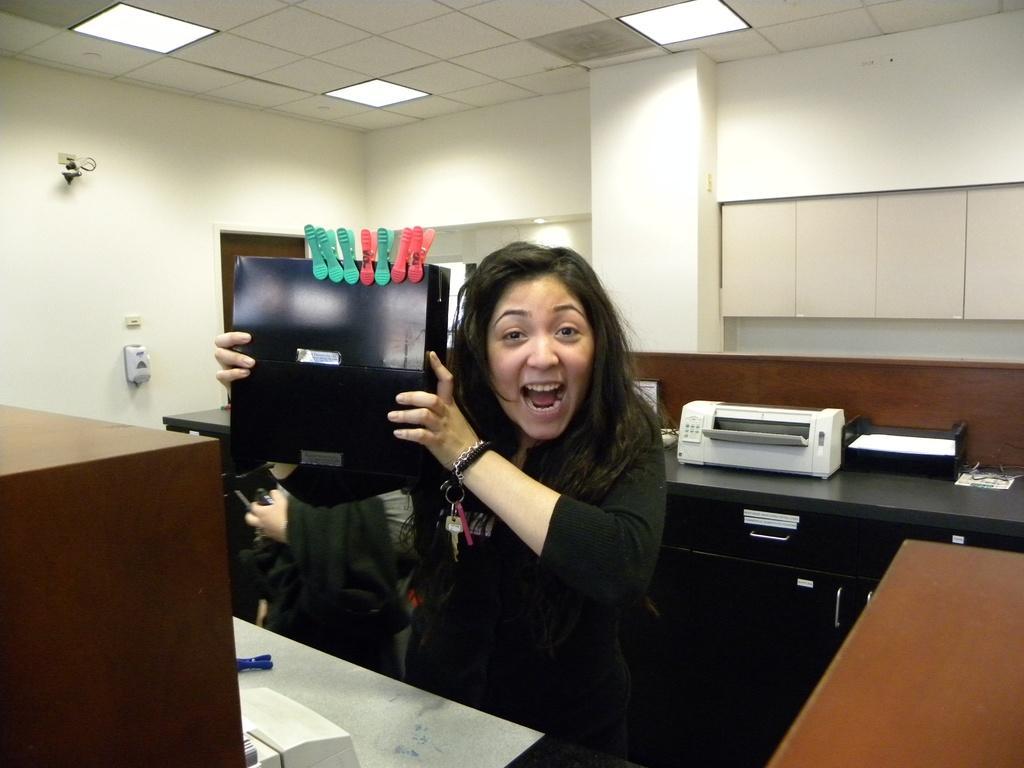Describe this image in one or two sentences. Here we can see a woman holding a box in her hand with clips on it and behind her we can see a printer 